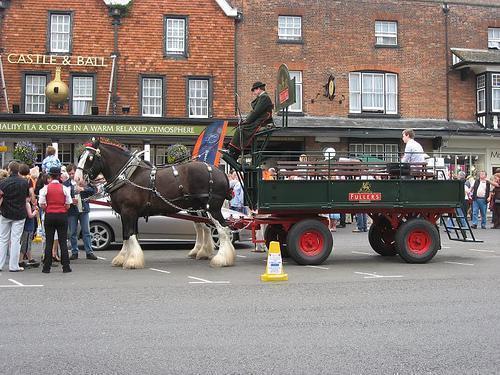What color are the bearings inside of the wagon wheels?
Select the correct answer and articulate reasoning with the following format: 'Answer: answer
Rationale: rationale.'
Options: White, purple, blue, red. Answer: red.
Rationale: The color is red. 